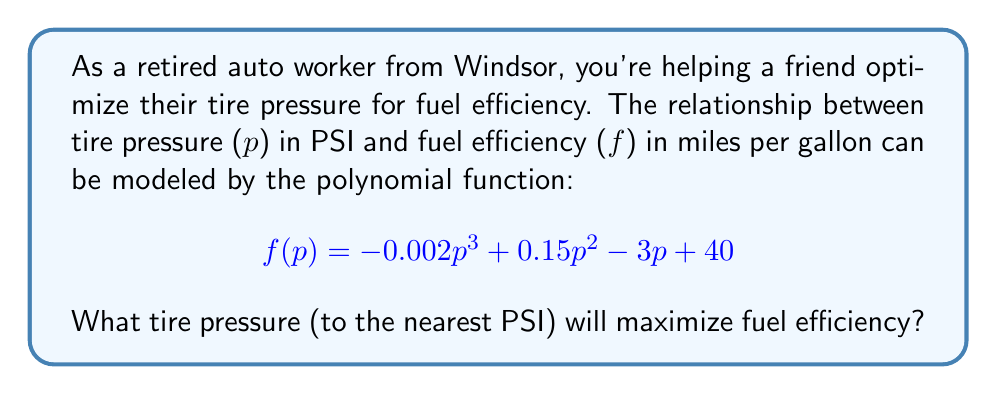Give your solution to this math problem. To find the optimal tire pressure, we need to find the maximum value of the function $f(p)$. This occurs where the derivative $f'(p)$ equals zero.

1) First, let's find the derivative $f'(p)$:
   $$ f'(p) = -0.006p^2 + 0.3p - 3 $$

2) Set $f'(p) = 0$ and solve for $p$:
   $$ -0.006p^2 + 0.3p - 3 = 0 $$

3) This is a quadratic equation. We can solve it using the quadratic formula:
   $$ p = \frac{-b \pm \sqrt{b^2 - 4ac}}{2a} $$
   where $a = -0.006$, $b = 0.3$, and $c = -3$

4) Plugging in these values:
   $$ p = \frac{-0.3 \pm \sqrt{0.3^2 - 4(-0.006)(-3)}}{2(-0.006)} $$
   $$ = \frac{-0.3 \pm \sqrt{0.09 - 0.072}}{-0.012} $$
   $$ = \frac{-0.3 \pm \sqrt{0.018}}{-0.012} $$
   $$ = \frac{-0.3 \pm 0.134164}{-0.012} $$

5) This gives us two solutions:
   $$ p_1 = \frac{-0.3 + 0.134164}{-0.012} \approx 13.82 $$
   $$ p_2 = \frac{-0.3 - 0.134164}{-0.012} \approx 36.18 $$

6) To determine which of these is the maximum (rather than the minimum), we can check the second derivative:
   $$ f''(p) = -0.012p + 0.3 $$

   At $p = 36.18$, $f''(36.18) < 0$, indicating this is the maximum.

7) Rounding to the nearest PSI, we get 36 PSI.
Answer: 36 PSI 